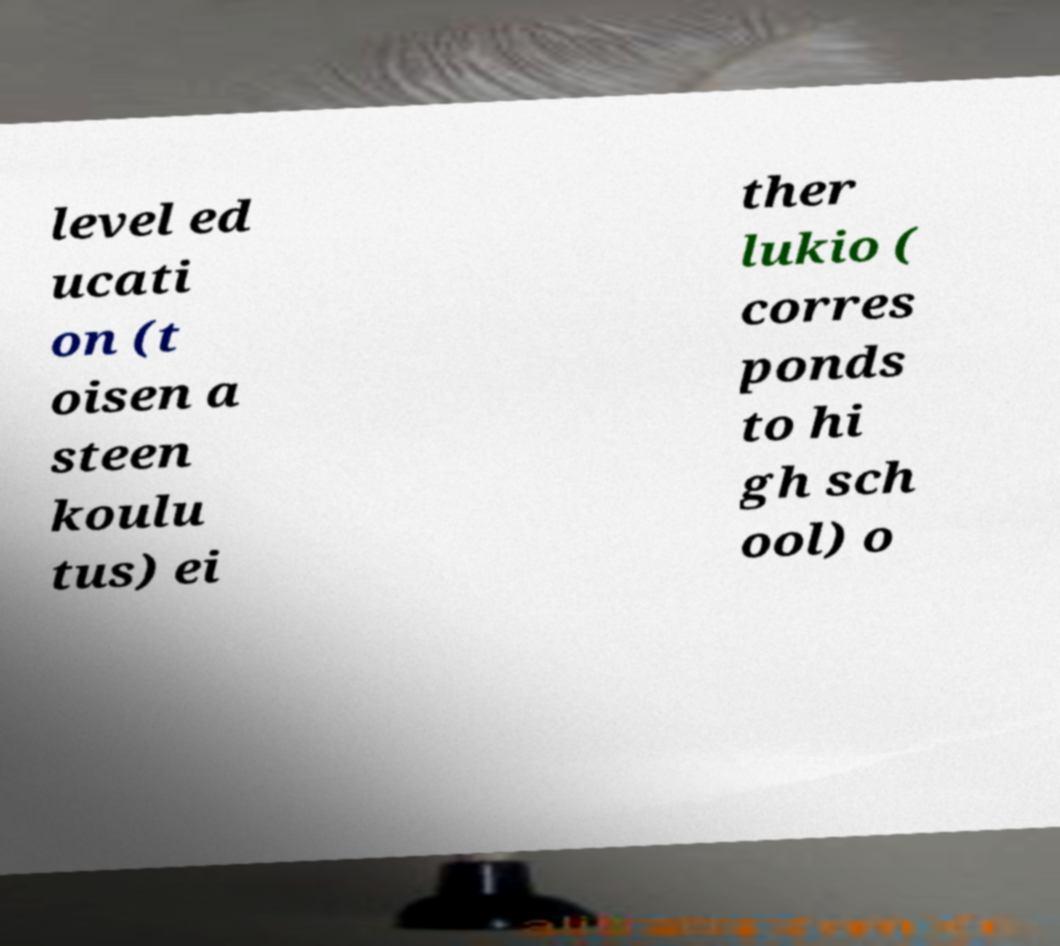What messages or text are displayed in this image? I need them in a readable, typed format. level ed ucati on (t oisen a steen koulu tus) ei ther lukio ( corres ponds to hi gh sch ool) o 